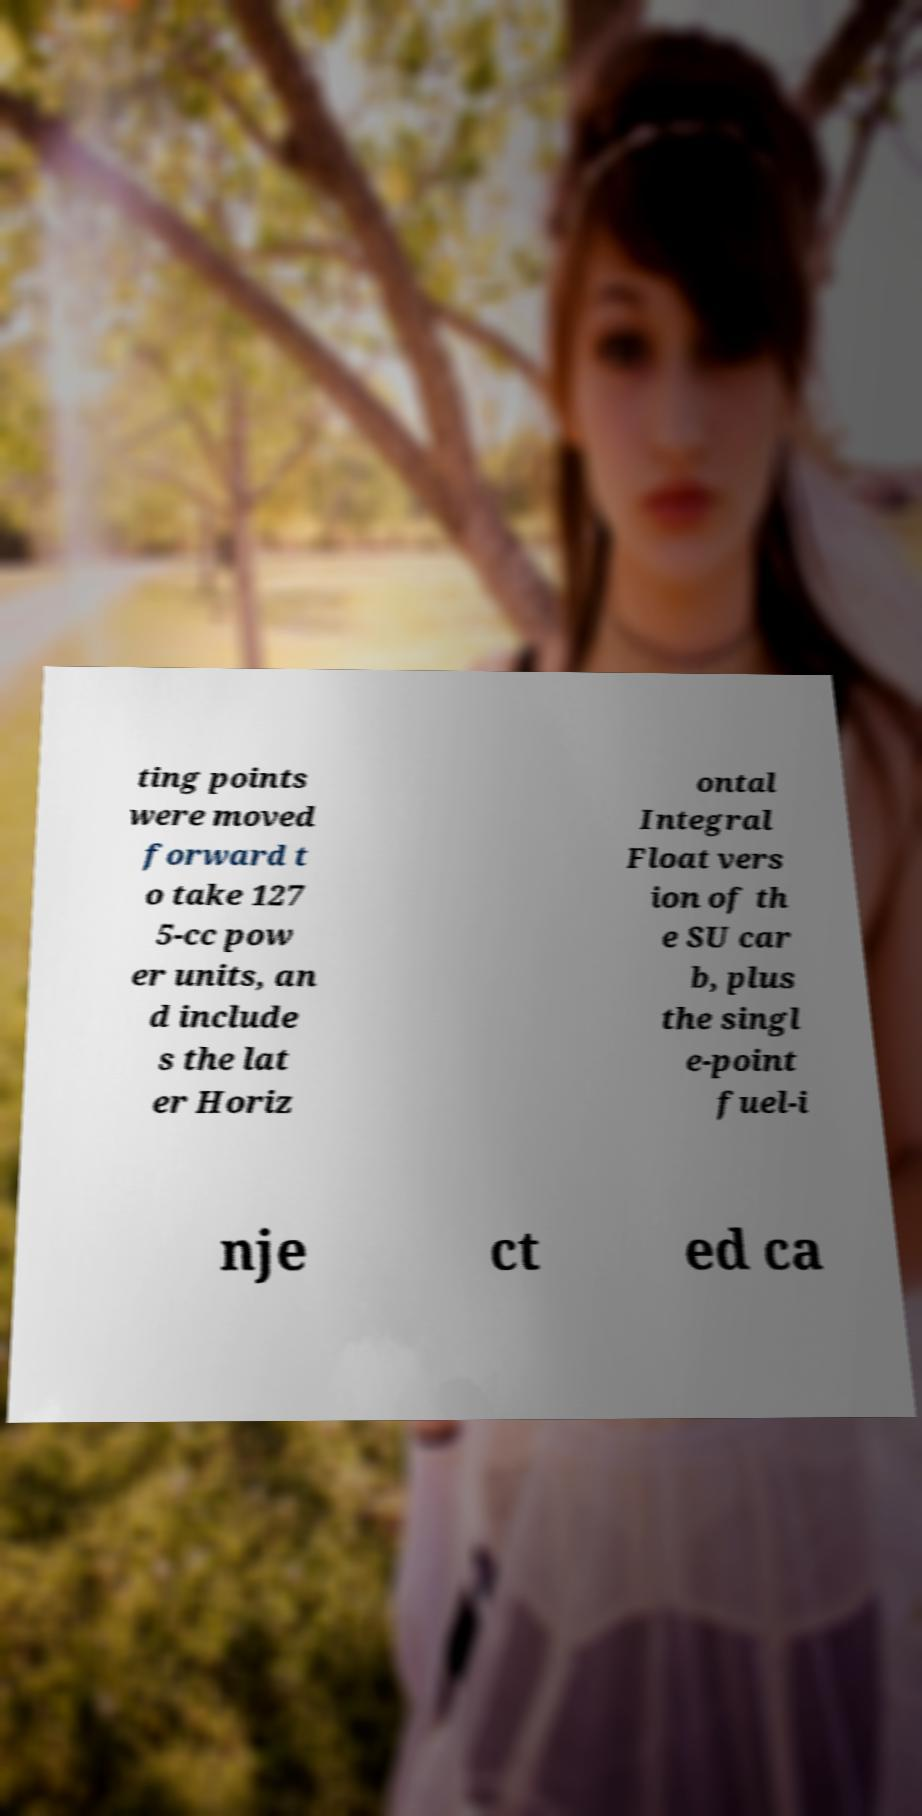Can you read and provide the text displayed in the image?This photo seems to have some interesting text. Can you extract and type it out for me? ting points were moved forward t o take 127 5-cc pow er units, an d include s the lat er Horiz ontal Integral Float vers ion of th e SU car b, plus the singl e-point fuel-i nje ct ed ca 